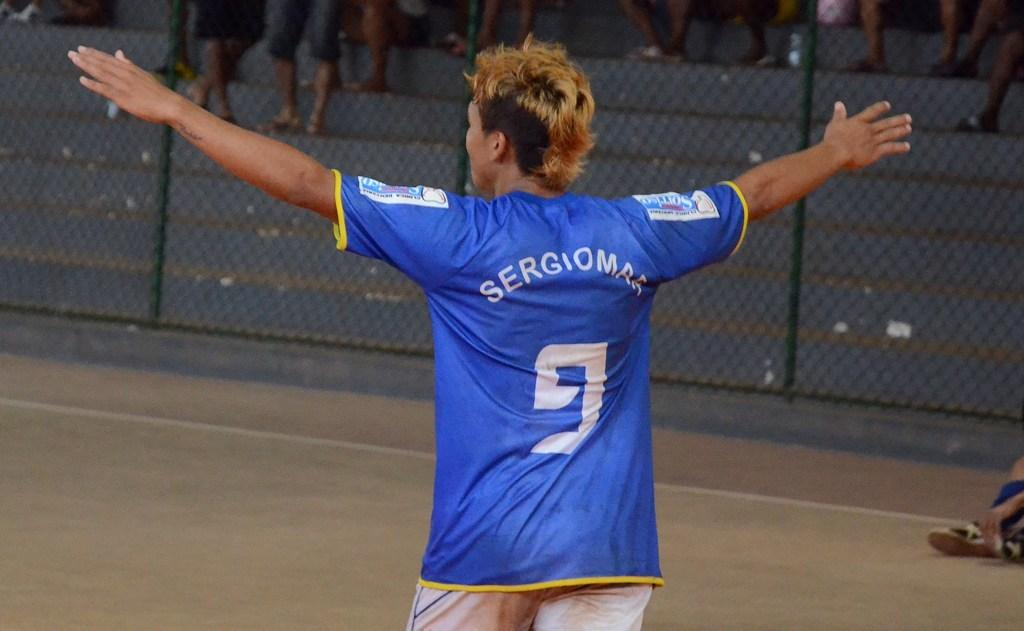What is the main subject of the image? The main subject of the image is a player. What is the player doing in the image? The player is standing and stretching his arms. What can be seen behind the player? There is a mesh behind the player. Are there any other people visible in the image? Yes, there are other people visible behind the mesh. What type of baseball is the player holding in the image? There is no baseball present in the image; the player is stretching his arms without holding any object. Can you see a carriage in the image? No, there is no carriage visible in the image. 